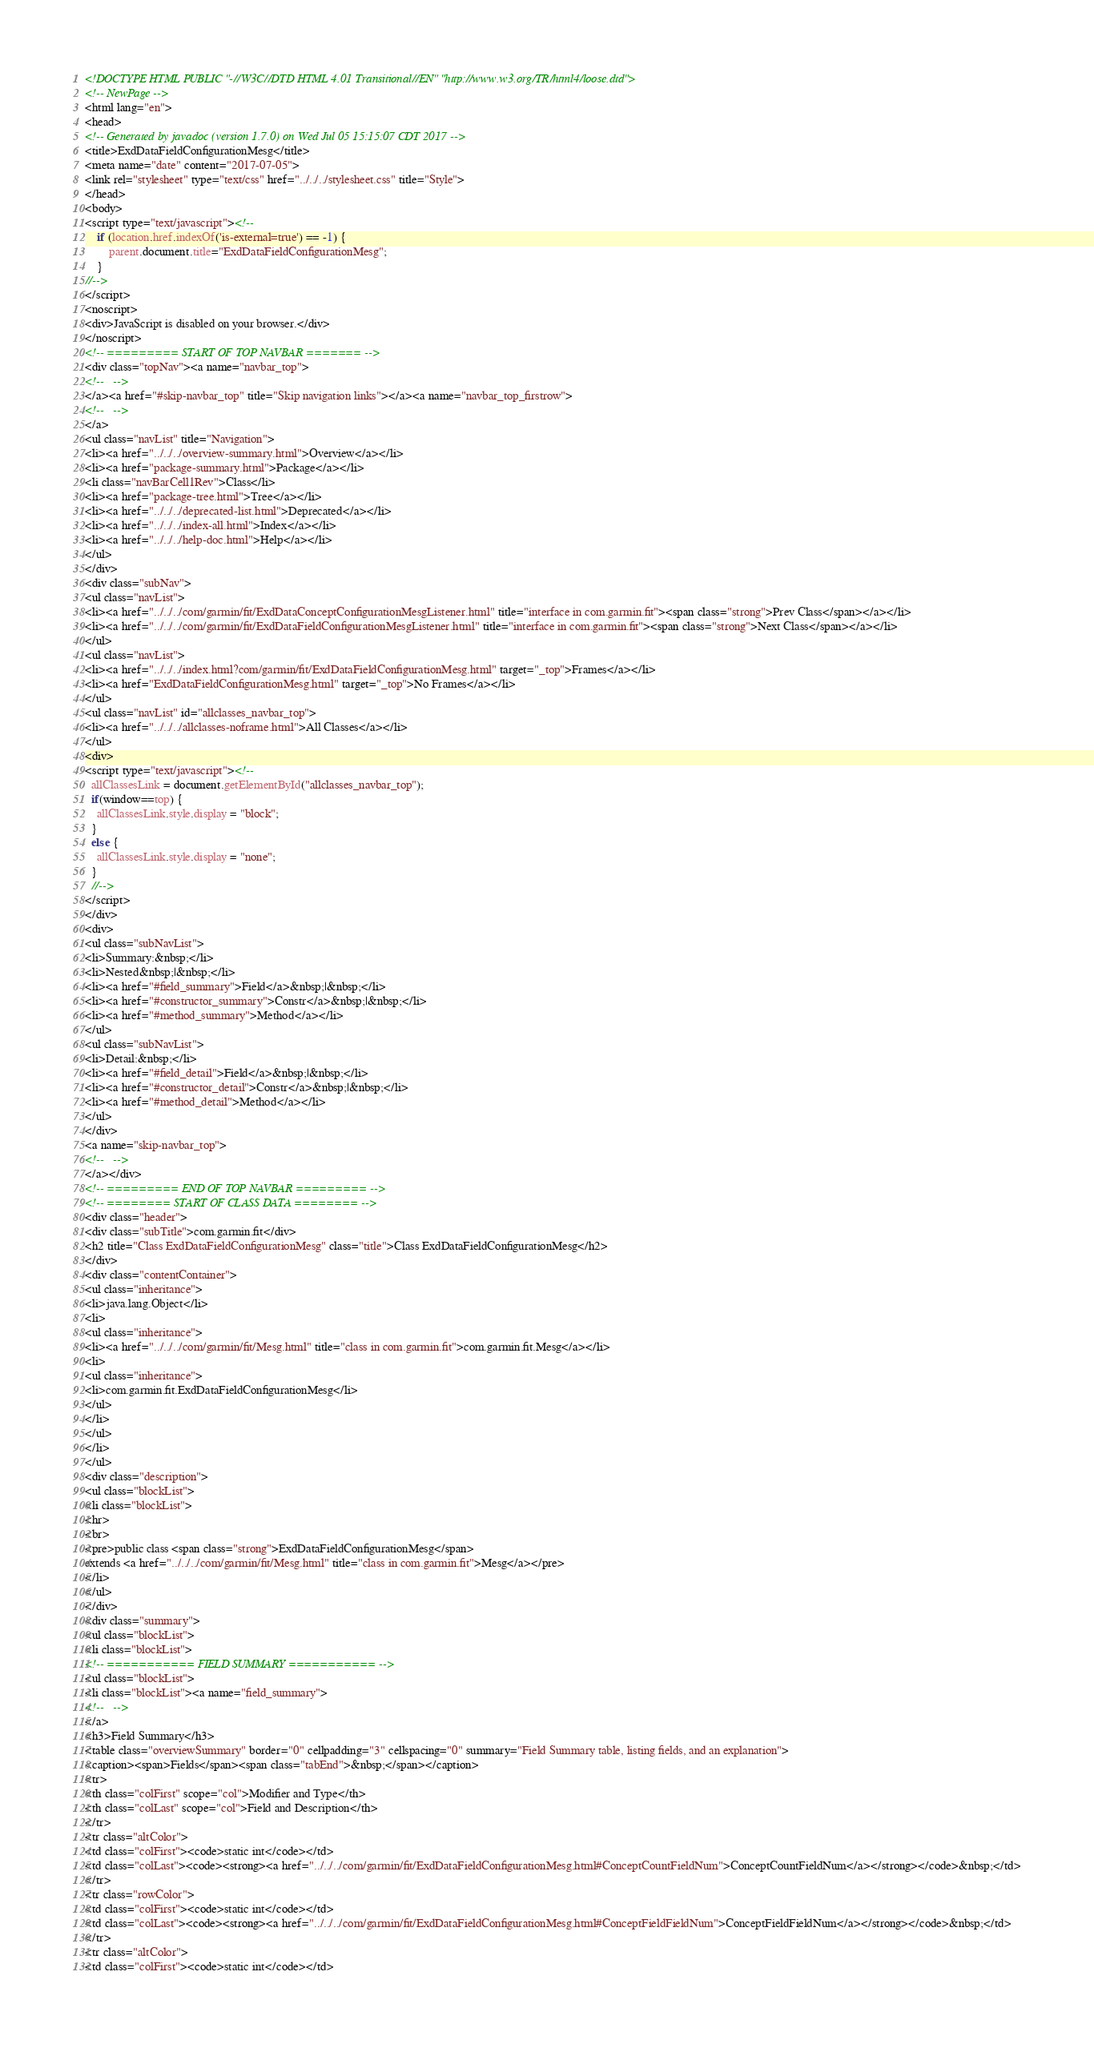<code> <loc_0><loc_0><loc_500><loc_500><_HTML_><!DOCTYPE HTML PUBLIC "-//W3C//DTD HTML 4.01 Transitional//EN" "http://www.w3.org/TR/html4/loose.dtd">
<!-- NewPage -->
<html lang="en">
<head>
<!-- Generated by javadoc (version 1.7.0) on Wed Jul 05 15:15:07 CDT 2017 -->
<title>ExdDataFieldConfigurationMesg</title>
<meta name="date" content="2017-07-05">
<link rel="stylesheet" type="text/css" href="../../../stylesheet.css" title="Style">
</head>
<body>
<script type="text/javascript"><!--
    if (location.href.indexOf('is-external=true') == -1) {
        parent.document.title="ExdDataFieldConfigurationMesg";
    }
//-->
</script>
<noscript>
<div>JavaScript is disabled on your browser.</div>
</noscript>
<!-- ========= START OF TOP NAVBAR ======= -->
<div class="topNav"><a name="navbar_top">
<!--   -->
</a><a href="#skip-navbar_top" title="Skip navigation links"></a><a name="navbar_top_firstrow">
<!--   -->
</a>
<ul class="navList" title="Navigation">
<li><a href="../../../overview-summary.html">Overview</a></li>
<li><a href="package-summary.html">Package</a></li>
<li class="navBarCell1Rev">Class</li>
<li><a href="package-tree.html">Tree</a></li>
<li><a href="../../../deprecated-list.html">Deprecated</a></li>
<li><a href="../../../index-all.html">Index</a></li>
<li><a href="../../../help-doc.html">Help</a></li>
</ul>
</div>
<div class="subNav">
<ul class="navList">
<li><a href="../../../com/garmin/fit/ExdDataConceptConfigurationMesgListener.html" title="interface in com.garmin.fit"><span class="strong">Prev Class</span></a></li>
<li><a href="../../../com/garmin/fit/ExdDataFieldConfigurationMesgListener.html" title="interface in com.garmin.fit"><span class="strong">Next Class</span></a></li>
</ul>
<ul class="navList">
<li><a href="../../../index.html?com/garmin/fit/ExdDataFieldConfigurationMesg.html" target="_top">Frames</a></li>
<li><a href="ExdDataFieldConfigurationMesg.html" target="_top">No Frames</a></li>
</ul>
<ul class="navList" id="allclasses_navbar_top">
<li><a href="../../../allclasses-noframe.html">All Classes</a></li>
</ul>
<div>
<script type="text/javascript"><!--
  allClassesLink = document.getElementById("allclasses_navbar_top");
  if(window==top) {
    allClassesLink.style.display = "block";
  }
  else {
    allClassesLink.style.display = "none";
  }
  //-->
</script>
</div>
<div>
<ul class="subNavList">
<li>Summary:&nbsp;</li>
<li>Nested&nbsp;|&nbsp;</li>
<li><a href="#field_summary">Field</a>&nbsp;|&nbsp;</li>
<li><a href="#constructor_summary">Constr</a>&nbsp;|&nbsp;</li>
<li><a href="#method_summary">Method</a></li>
</ul>
<ul class="subNavList">
<li>Detail:&nbsp;</li>
<li><a href="#field_detail">Field</a>&nbsp;|&nbsp;</li>
<li><a href="#constructor_detail">Constr</a>&nbsp;|&nbsp;</li>
<li><a href="#method_detail">Method</a></li>
</ul>
</div>
<a name="skip-navbar_top">
<!--   -->
</a></div>
<!-- ========= END OF TOP NAVBAR ========= -->
<!-- ======== START OF CLASS DATA ======== -->
<div class="header">
<div class="subTitle">com.garmin.fit</div>
<h2 title="Class ExdDataFieldConfigurationMesg" class="title">Class ExdDataFieldConfigurationMesg</h2>
</div>
<div class="contentContainer">
<ul class="inheritance">
<li>java.lang.Object</li>
<li>
<ul class="inheritance">
<li><a href="../../../com/garmin/fit/Mesg.html" title="class in com.garmin.fit">com.garmin.fit.Mesg</a></li>
<li>
<ul class="inheritance">
<li>com.garmin.fit.ExdDataFieldConfigurationMesg</li>
</ul>
</li>
</ul>
</li>
</ul>
<div class="description">
<ul class="blockList">
<li class="blockList">
<hr>
<br>
<pre>public class <span class="strong">ExdDataFieldConfigurationMesg</span>
extends <a href="../../../com/garmin/fit/Mesg.html" title="class in com.garmin.fit">Mesg</a></pre>
</li>
</ul>
</div>
<div class="summary">
<ul class="blockList">
<li class="blockList">
<!-- =========== FIELD SUMMARY =========== -->
<ul class="blockList">
<li class="blockList"><a name="field_summary">
<!--   -->
</a>
<h3>Field Summary</h3>
<table class="overviewSummary" border="0" cellpadding="3" cellspacing="0" summary="Field Summary table, listing fields, and an explanation">
<caption><span>Fields</span><span class="tabEnd">&nbsp;</span></caption>
<tr>
<th class="colFirst" scope="col">Modifier and Type</th>
<th class="colLast" scope="col">Field and Description</th>
</tr>
<tr class="altColor">
<td class="colFirst"><code>static int</code></td>
<td class="colLast"><code><strong><a href="../../../com/garmin/fit/ExdDataFieldConfigurationMesg.html#ConceptCountFieldNum">ConceptCountFieldNum</a></strong></code>&nbsp;</td>
</tr>
<tr class="rowColor">
<td class="colFirst"><code>static int</code></td>
<td class="colLast"><code><strong><a href="../../../com/garmin/fit/ExdDataFieldConfigurationMesg.html#ConceptFieldFieldNum">ConceptFieldFieldNum</a></strong></code>&nbsp;</td>
</tr>
<tr class="altColor">
<td class="colFirst"><code>static int</code></td></code> 